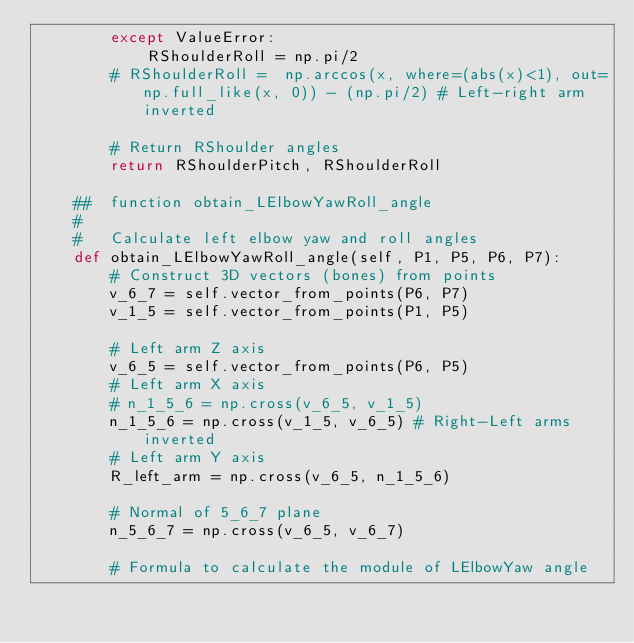Convert code to text. <code><loc_0><loc_0><loc_500><loc_500><_Python_>        except ValueError:
            RShoulderRoll = np.pi/2
        # RShoulderRoll =  np.arccos(x, where=(abs(x)<1), out=np.full_like(x, 0)) - (np.pi/2) # Left-right arm inverted

        # Return RShoulder angles
        return RShoulderPitch, RShoulderRoll

    ##  function obtain_LElbowYawRoll_angle
    #   
    #   Calculate left elbow yaw and roll angles
    def obtain_LElbowYawRoll_angle(self, P1, P5, P6, P7):
        # Construct 3D vectors (bones) from points
        v_6_7 = self.vector_from_points(P6, P7)
        v_1_5 = self.vector_from_points(P1, P5)

        # Left arm Z axis
        v_6_5 = self.vector_from_points(P6, P5)
        # Left arm X axis
        # n_1_5_6 = np.cross(v_6_5, v_1_5) 
        n_1_5_6 = np.cross(v_1_5, v_6_5) # Right-Left arms inverted
        # Left arm Y axis
        R_left_arm = np.cross(v_6_5, n_1_5_6)

        # Normal of 5_6_7 plane
        n_5_6_7 = np.cross(v_6_5, v_6_7) 

        # Formula to calculate the module of LElbowYaw angle</code> 